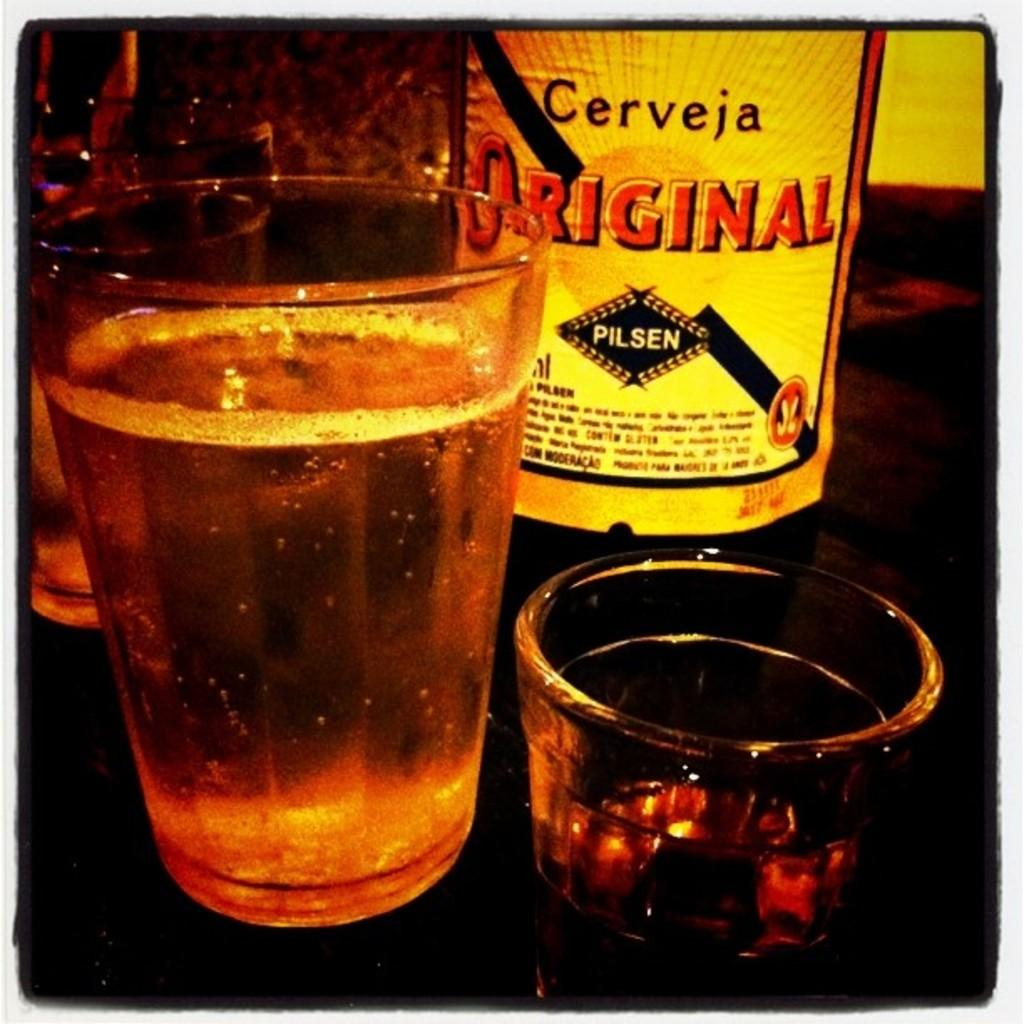What type of containers are visible in the image? There are glasses and bottles with beverages in the image. Where are the glasses and bottles located? The glasses and bottles are placed on a table. What might be the contents of the containers in the image? The contents of the containers are likely beverages, as indicated by the facts. Can you tell me how deep the river is in the image? There is no river present in the image; it features glasses and bottles with beverages on a table. 